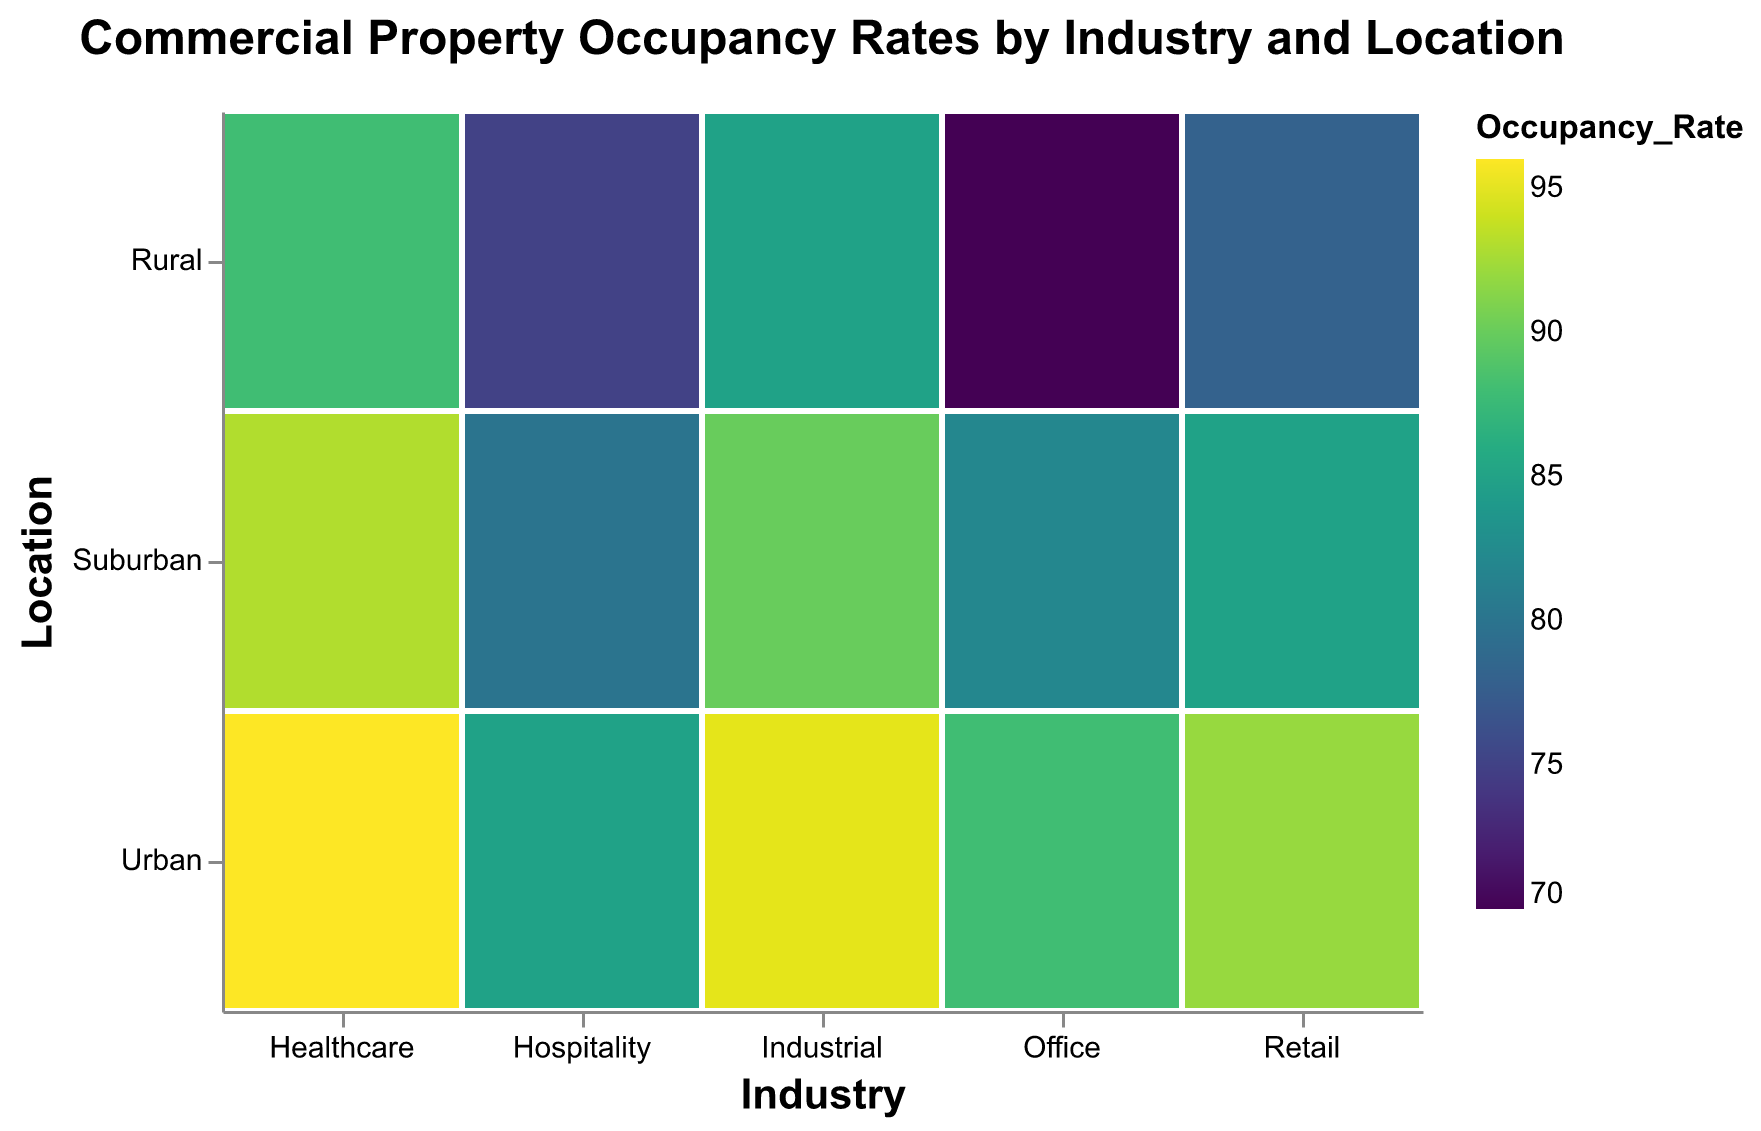What is the title of the plot? The title of the plot is the text at the top of the figure. It helps viewers quickly understand what the figure is about.
Answer: Commercial Property Occupancy Rates by Industry and Location Which industry has the highest occupancy rate in urban locations? Check the color intensity in the Urban row for each industry. Darker color indicates a higher occupancy rate.
Answer: Healthcare What is the difference in occupancy rates between urban and rural locations for the Hospitality industry? Identify the colors corresponding to Hospitality in Urban and Rural locations. Urban has an occupancy rate of 85, and Rural has 75. Calculate the difference (85-75).
Answer: 10 What sector has the lowest occupancy rate, and at which location type does it occur? Identify the lightest colored cell in the entire plot, which represents the lowest occupancy rate.
Answer: Office in Rural Which location type has the highest average occupancy rate across all sectors? Calculate the average color rating for Urban, Suburban, and Rural across all industries. Urban appears to be the darkest overall.
Answer: Urban What is the ratio of the occupancy rate of Industrial properties in Urban locations to those in Rural locations? Urban occupancy for Industrial is 95. Rural occupancy for Industrial is 85. Calculate the ratio (95/85).
Answer: 1.12 Does any industry have the same occupancy rates across all three location types? Compare color shades across Urban, Suburban, and Rural for each industry. Look for an industry where these shades are the same.
Answer: No What is the sum of the occupancy rates for Retail properties across all location types? Add up the occupancy rates for Retail in Urban (92), Suburban (85), and Rural (78). (92 + 85 + 78)
Answer: 255 Which sector shows the greatest variation in occupancy rates across different location types? Assess the difference between the highest and lowest occupancy rates within each industry by comparing the color gradients. Office has the most marked variation from 88 (Urban) to 70 (Rural).
Answer: Office Which location type tends to have the lowest occupancy rates across all industries? Evaluate color intensities for each location type. Compare across all sectors. Rural appears to consistently have lighter colors.
Answer: Rural 